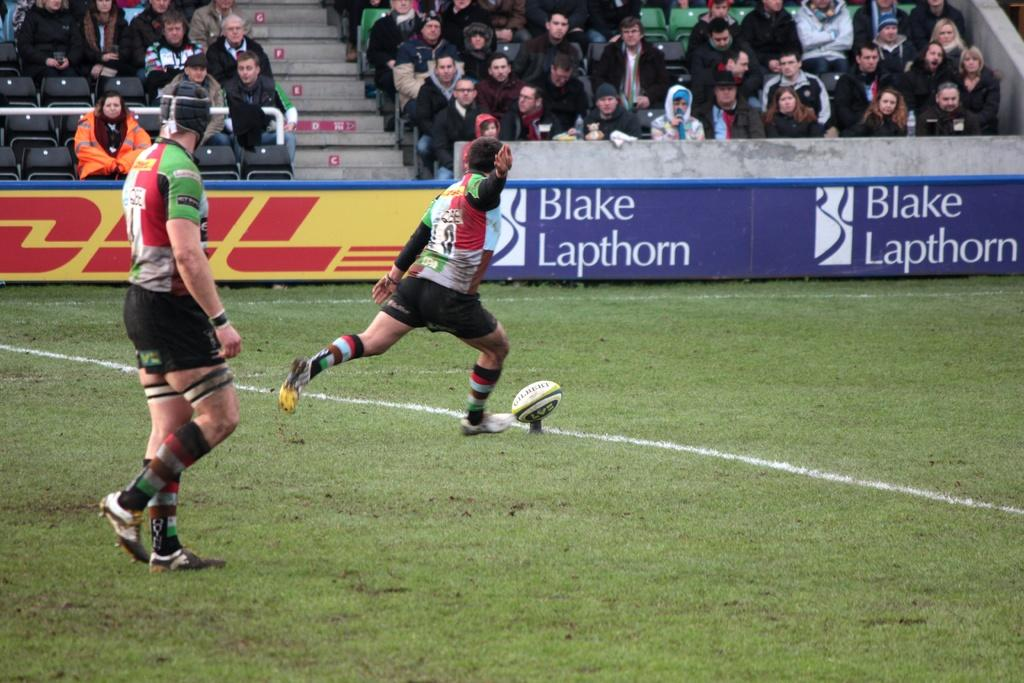<image>
Share a concise interpretation of the image provided. A player gets ready to kick the ball in front of a sign for Black Lapthorn. 